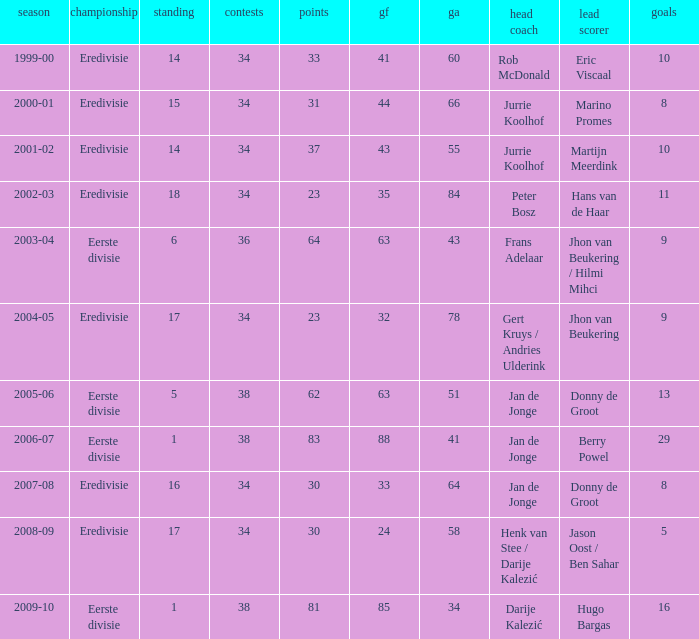How many seasons had a rank of 16? 1.0. 